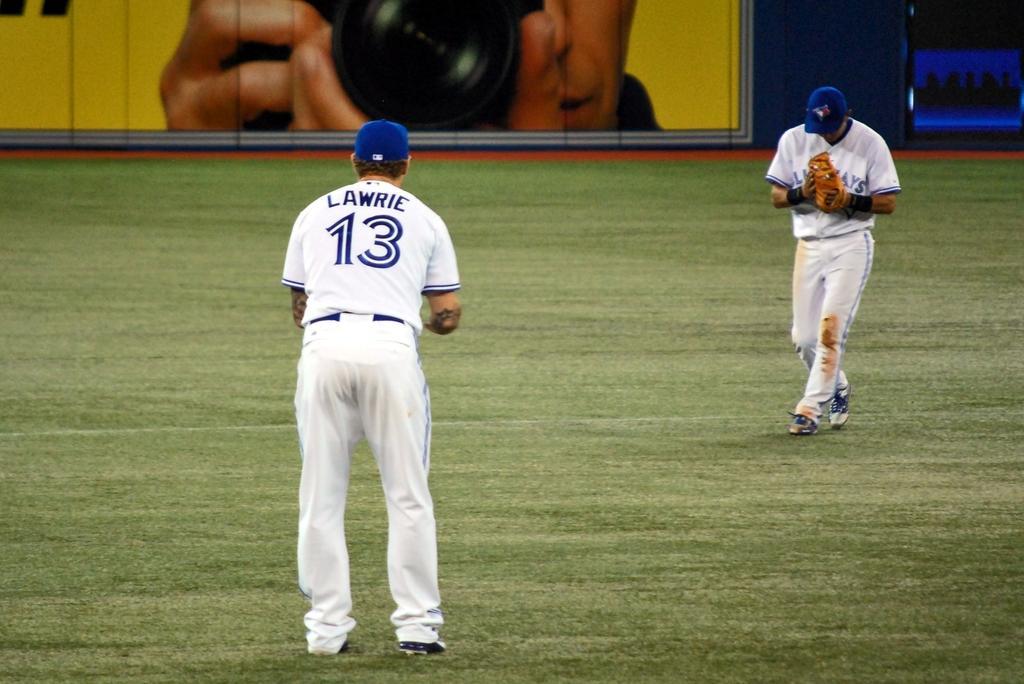Could you give a brief overview of what you see in this image? In this image I can see two persons standing on ground and they both are wearing a white color dress and blue color cap and at the top I can see photo of person holding camera. 